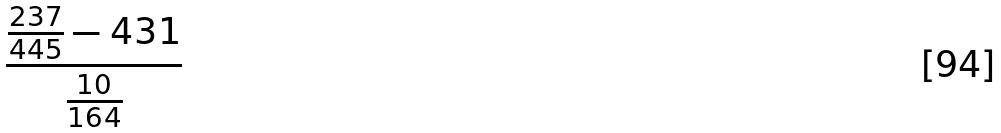Convert formula to latex. <formula><loc_0><loc_0><loc_500><loc_500>\frac { \frac { 2 3 7 } { 4 4 5 } - 4 3 1 } { \frac { 1 0 } { 1 6 4 } }</formula> 